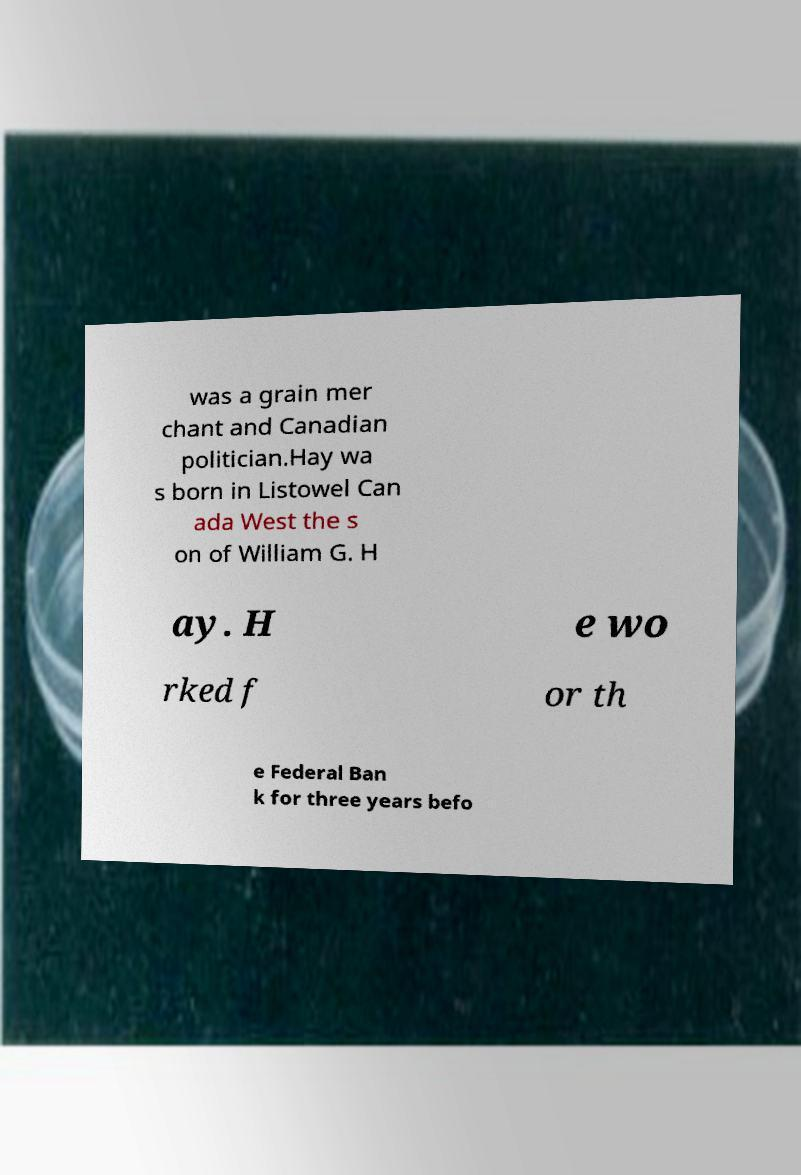Please read and relay the text visible in this image. What does it say? was a grain mer chant and Canadian politician.Hay wa s born in Listowel Can ada West the s on of William G. H ay. H e wo rked f or th e Federal Ban k for three years befo 